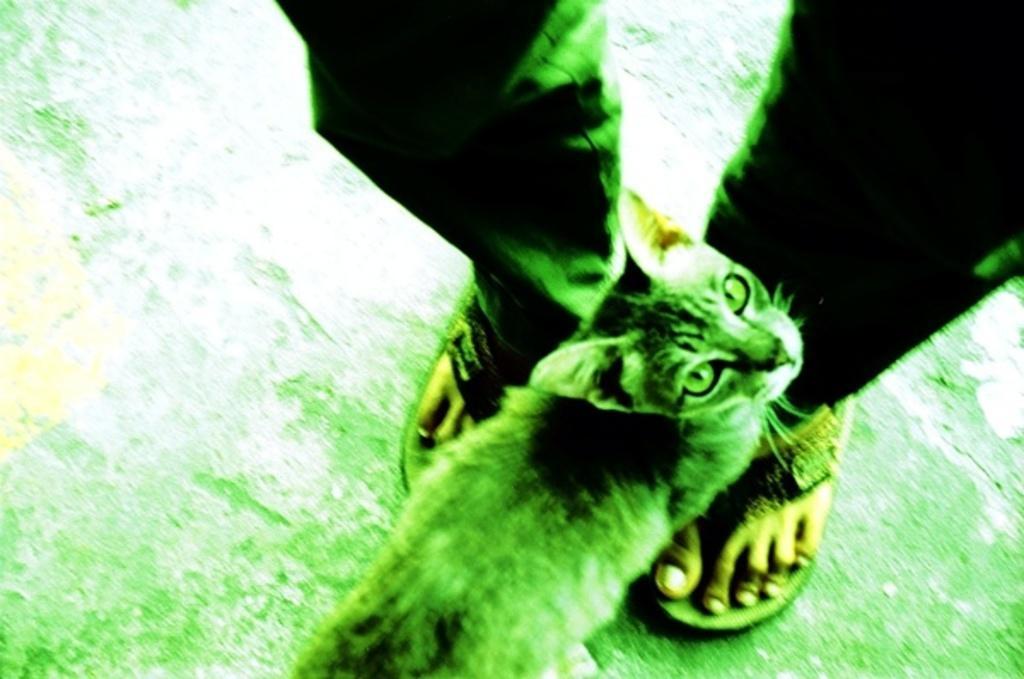Describe this image in one or two sentences. In this picture I can see a cat near to a person's legs and I see that this image is of white and green color. 